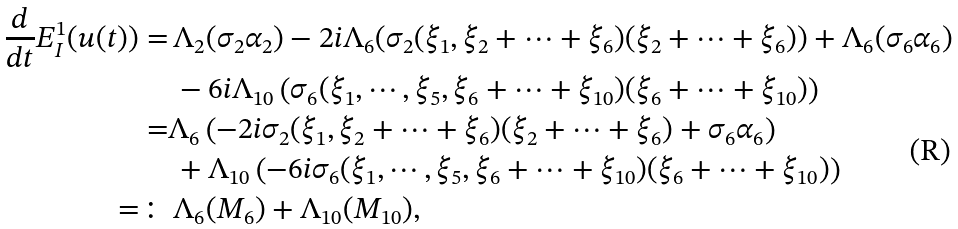Convert formula to latex. <formula><loc_0><loc_0><loc_500><loc_500>\frac { d } { d t } E ^ { 1 } _ { I } ( u ( t ) ) = & \, \Lambda _ { 2 } ( \sigma _ { 2 } \alpha _ { 2 } ) - 2 i \Lambda _ { 6 } ( \sigma _ { 2 } ( \xi _ { 1 } , \xi _ { 2 } + \cdots + \xi _ { 6 } ) ( \xi _ { 2 } + \cdots + \xi _ { 6 } ) ) + \Lambda _ { 6 } ( \sigma _ { 6 } \alpha _ { 6 } ) \\ & \, - 6 i \Lambda _ { 1 0 } \left ( \sigma _ { 6 } ( \xi _ { 1 } , \cdots , \xi _ { 5 } , \xi _ { 6 } + \cdots + \xi _ { 1 0 } ) ( \xi _ { 6 } + \cdots + \xi _ { 1 0 } ) \right ) \\ = & \Lambda _ { 6 } \left ( - 2 i \sigma _ { 2 } ( \xi _ { 1 } , \xi _ { 2 } + \cdots + \xi _ { 6 } ) ( \xi _ { 2 } + \cdots + \xi _ { 6 } ) + \sigma _ { 6 } \alpha _ { 6 } \right ) \\ & \, + \Lambda _ { 1 0 } \left ( - 6 i \sigma _ { 6 } ( \xi _ { 1 } , \cdots , \xi _ { 5 } , \xi _ { 6 } + \cdots + \xi _ { 1 0 } ) ( \xi _ { 6 } + \cdots + \xi _ { 1 0 } ) \right ) \\ = \colon & \, \Lambda _ { 6 } ( M _ { 6 } ) + \Lambda _ { 1 0 } ( M _ { 1 0 } ) ,</formula> 